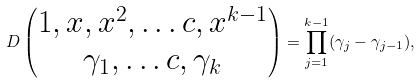<formula> <loc_0><loc_0><loc_500><loc_500>D \begin{pmatrix} 1 , x , x ^ { 2 } , \dots c , x ^ { k - 1 } \\ \gamma _ { 1 } , \dots c , \gamma _ { k } \end{pmatrix} = \prod _ { j = 1 } ^ { k - 1 } ( \gamma _ { j } - \gamma _ { j - 1 } ) ,</formula> 